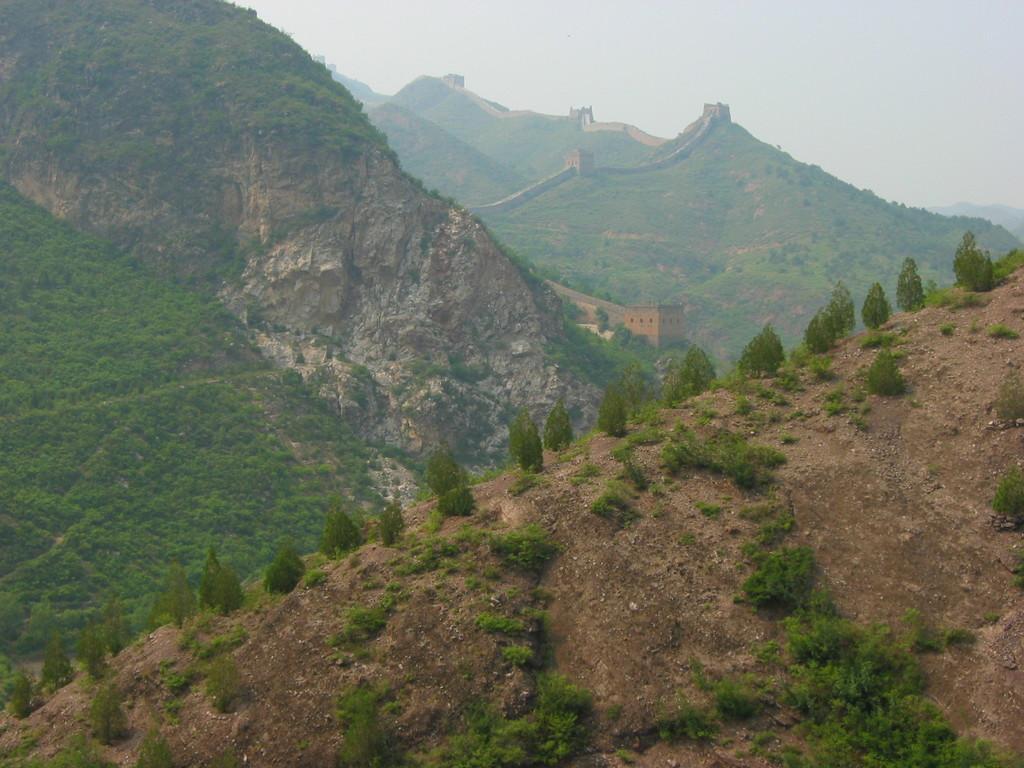Please provide a concise description of this image. In this image I can see mountains, grass and the Great Wall of China. On the top right side of the image I can see the sky. 